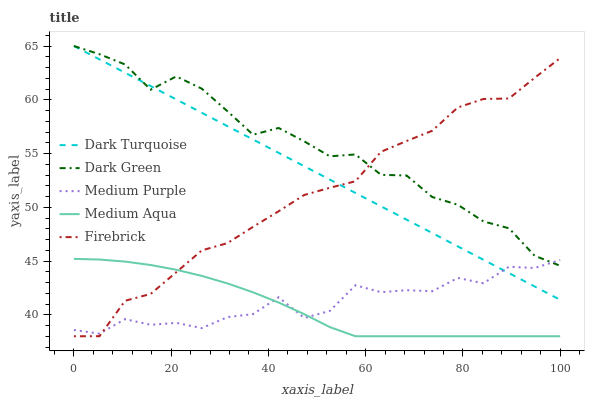Does Medium Aqua have the minimum area under the curve?
Answer yes or no. Yes. Does Dark Green have the maximum area under the curve?
Answer yes or no. Yes. Does Dark Turquoise have the minimum area under the curve?
Answer yes or no. No. Does Dark Turquoise have the maximum area under the curve?
Answer yes or no. No. Is Dark Turquoise the smoothest?
Answer yes or no. Yes. Is Medium Purple the roughest?
Answer yes or no. Yes. Is Firebrick the smoothest?
Answer yes or no. No. Is Firebrick the roughest?
Answer yes or no. No. Does Firebrick have the lowest value?
Answer yes or no. Yes. Does Dark Turquoise have the lowest value?
Answer yes or no. No. Does Dark Green have the highest value?
Answer yes or no. Yes. Does Firebrick have the highest value?
Answer yes or no. No. Is Medium Aqua less than Dark Turquoise?
Answer yes or no. Yes. Is Dark Green greater than Medium Aqua?
Answer yes or no. Yes. Does Medium Aqua intersect Medium Purple?
Answer yes or no. Yes. Is Medium Aqua less than Medium Purple?
Answer yes or no. No. Is Medium Aqua greater than Medium Purple?
Answer yes or no. No. Does Medium Aqua intersect Dark Turquoise?
Answer yes or no. No. 